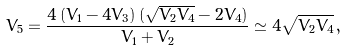<formula> <loc_0><loc_0><loc_500><loc_500>V _ { 5 } = \frac { 4 \, ( V _ { 1 } - 4 V _ { 3 } ) \, ( \sqrt { V _ { 2 } V _ { 4 } } - 2 V _ { 4 } ) } { V _ { 1 } + V _ { 2 } } \simeq 4 \sqrt { V _ { 2 } V _ { 4 } } \, ,</formula> 